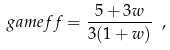Convert formula to latex. <formula><loc_0><loc_0><loc_500><loc_500>\ g a m e f f = \frac { 5 + 3 w } { 3 ( 1 + w ) } \ ,</formula> 